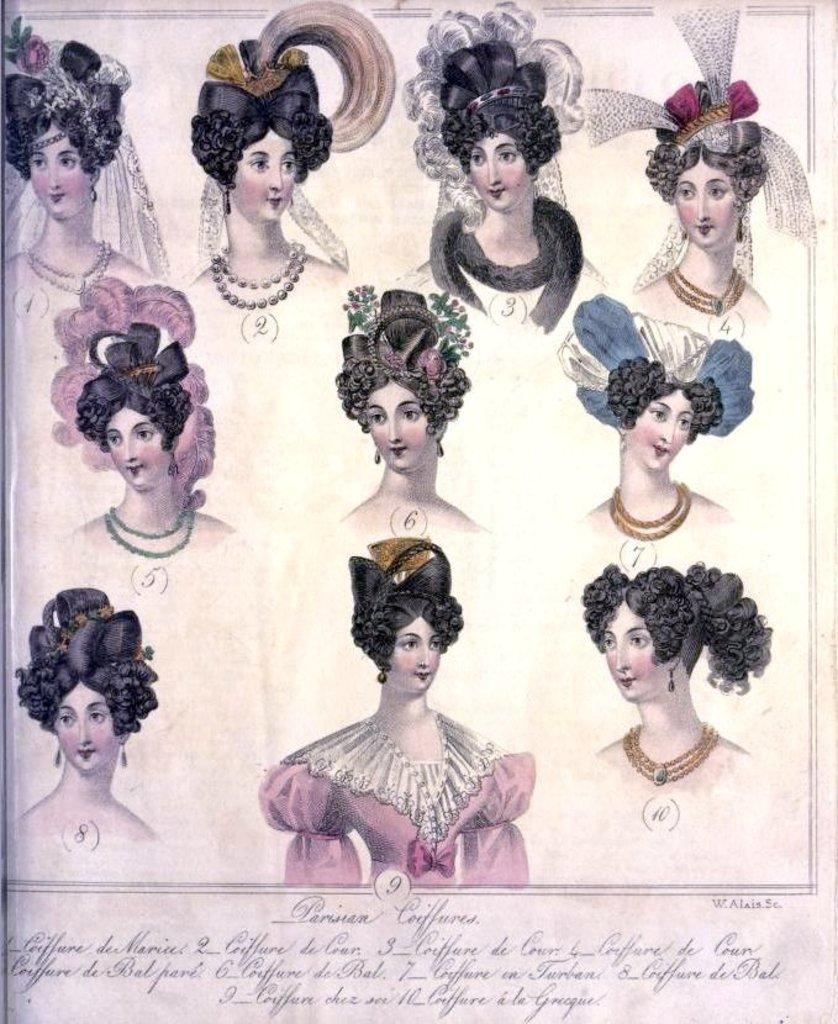What is depicted in the image? The image contains a sketch of a woman. What is the woman in the sketch wearing? The woman in the sketch is wearing different head wear. What is the medium of the sketch? The sketch is on a paper. Is there any text in the image? Yes, there is writing at the bottom of the image. What is the name of the woman's friend in the image? There is no friend mentioned or depicted in the image, as it only contains a sketch of a woman. How many mint leaves are visible in the image? There are no mint leaves present in the image; it features a sketch of a woman with head wear and writing at the bottom. 